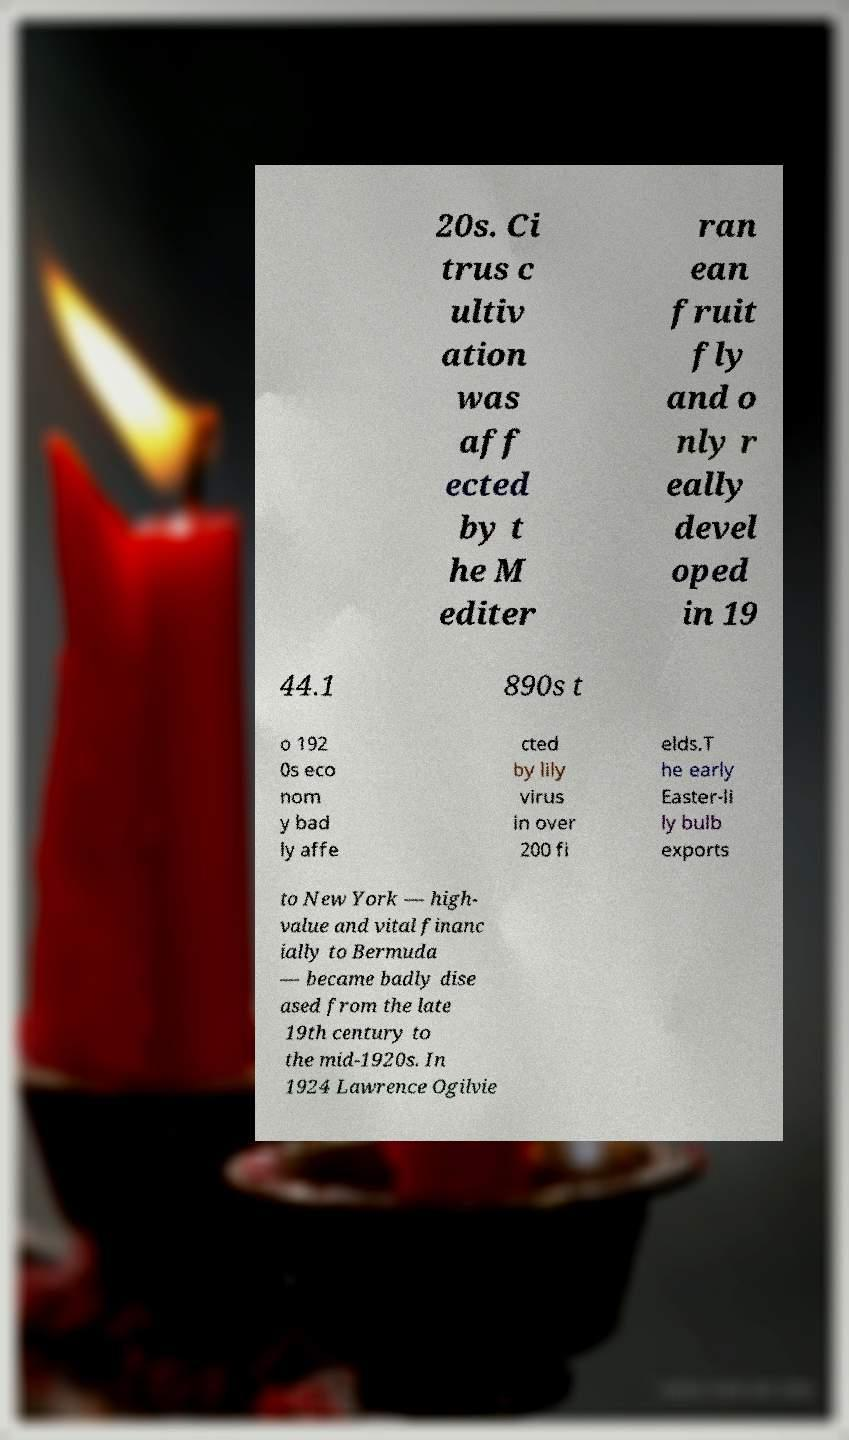What messages or text are displayed in this image? I need them in a readable, typed format. 20s. Ci trus c ultiv ation was aff ected by t he M editer ran ean fruit fly and o nly r eally devel oped in 19 44.1 890s t o 192 0s eco nom y bad ly affe cted by lily virus in over 200 fi elds.T he early Easter-li ly bulb exports to New York — high- value and vital financ ially to Bermuda — became badly dise ased from the late 19th century to the mid-1920s. In 1924 Lawrence Ogilvie 